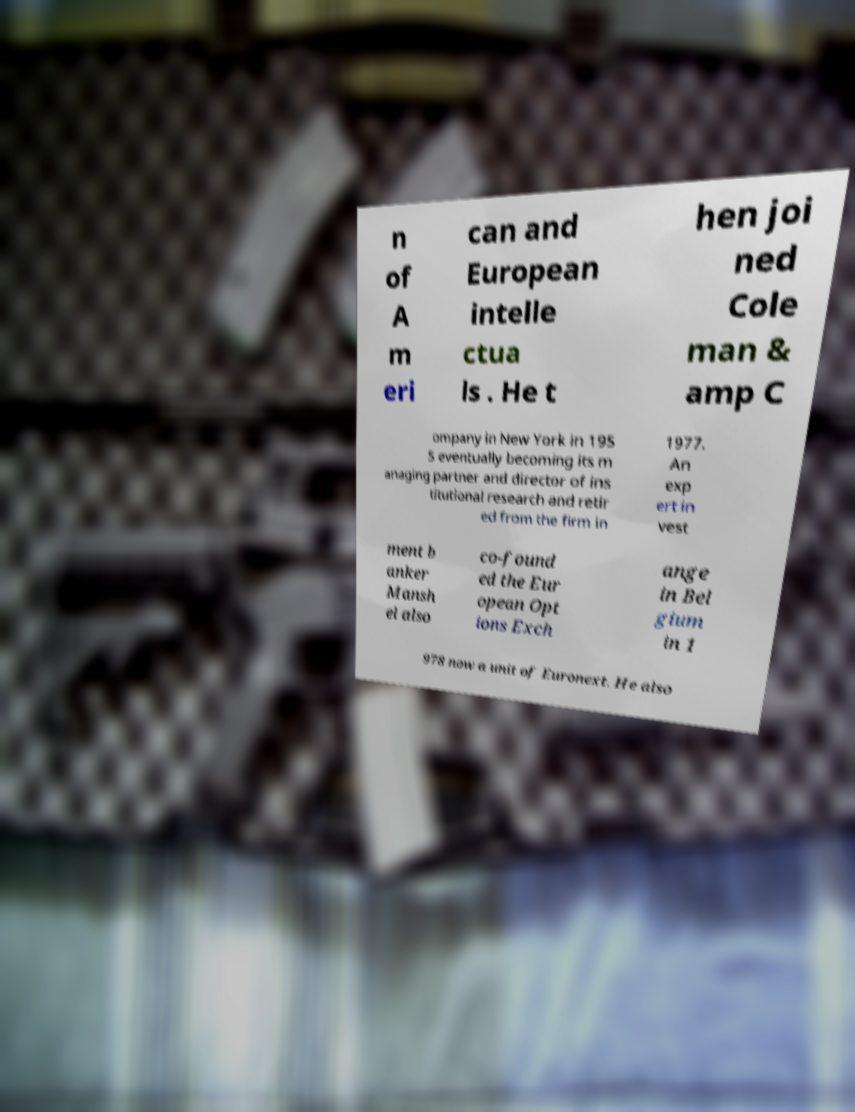Please read and relay the text visible in this image. What does it say? n of A m eri can and European intelle ctua ls . He t hen joi ned Cole man & amp C ompany in New York in 195 5 eventually becoming its m anaging partner and director of ins titutional research and retir ed from the firm in 1977. An exp ert in vest ment b anker Mansh el also co-found ed the Eur opean Opt ions Exch ange in Bel gium in 1 978 now a unit of Euronext. He also 